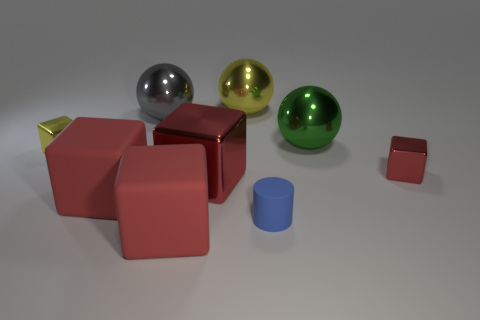Is the shape of the large green thing the same as the gray metal thing?
Provide a short and direct response. Yes. The thing that is right of the big ball to the right of the yellow sphere is what color?
Give a very brief answer. Red. Is there a sphere that has the same material as the yellow cube?
Offer a terse response. Yes. There is a yellow thing in front of the large gray metallic sphere behind the big green metal thing; what is it made of?
Make the answer very short. Metal. How many small yellow things have the same shape as the green metallic object?
Provide a succinct answer. 0. The tiny yellow shiny object is what shape?
Your response must be concise. Cube. Is the number of tiny yellow blocks less than the number of tiny blue metal objects?
Give a very brief answer. No. Are there more small rubber cylinders than red objects?
Provide a short and direct response. No. What number of other things are the same color as the small cylinder?
Provide a short and direct response. 0. Do the gray sphere and the cube that is on the right side of the large yellow shiny sphere have the same material?
Make the answer very short. Yes. 